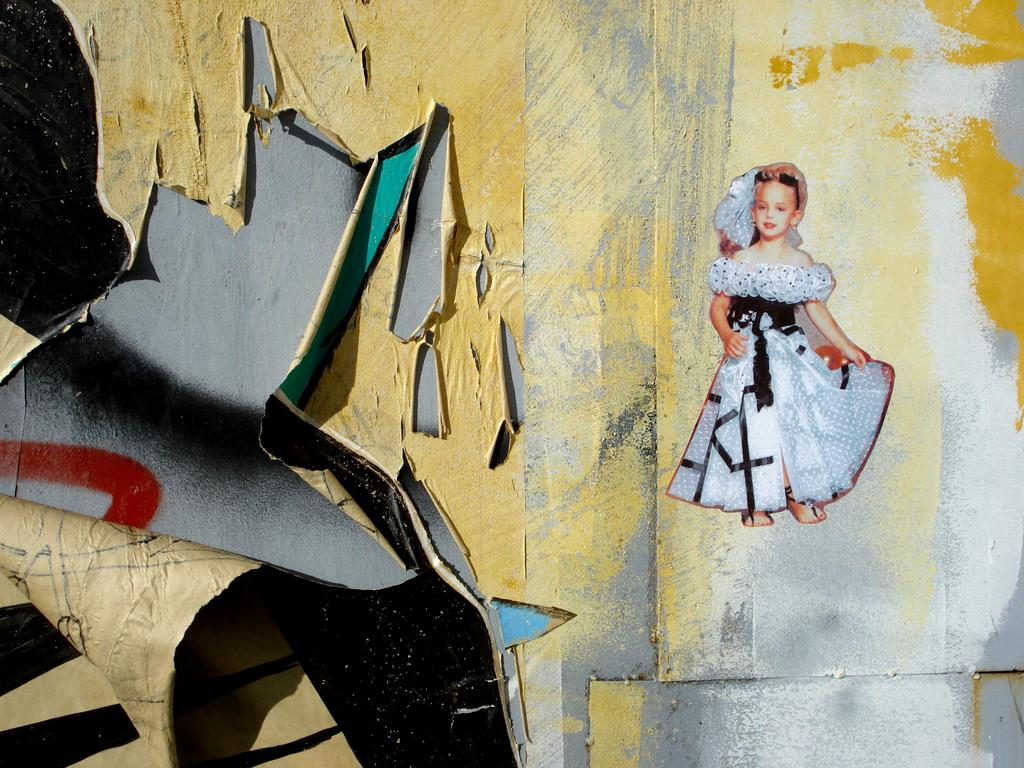What is depicted on the wallpaper sticker in the image? There is a wallpaper sticker of a small girl in the image. What is the girl wearing in the image? The girl is wearing a white dress in the image. Where is the tone wallpaper located in the image? The tone wallpaper is in the left corner of the image. What is the profit of the small girl's father in the image? There is no information about the girl's father or any profit in the image. 